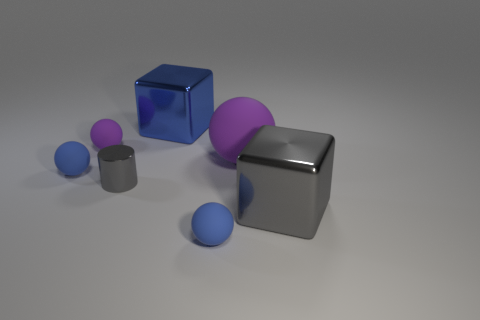What number of other things are there of the same size as the gray cube?
Your response must be concise. 2. What number of objects are either tiny matte things on the right side of the small purple ball or cylinders?
Ensure brevity in your answer.  2. The small metallic cylinder is what color?
Ensure brevity in your answer.  Gray. What is the material of the gray thing that is on the right side of the shiny cylinder?
Your answer should be very brief. Metal. Does the blue metal object have the same shape as the object that is right of the big rubber ball?
Offer a very short reply. Yes. Is the number of small green shiny balls greater than the number of purple matte things?
Give a very brief answer. No. Is there any other thing that has the same color as the cylinder?
Make the answer very short. Yes. There is a purple object that is the same material as the large sphere; what shape is it?
Your answer should be compact. Sphere. What is the material of the small blue object that is to the left of the blue matte thing in front of the big gray object?
Provide a short and direct response. Rubber. There is a gray object that is to the left of the blue shiny cube; is its shape the same as the large purple matte object?
Offer a terse response. No. 